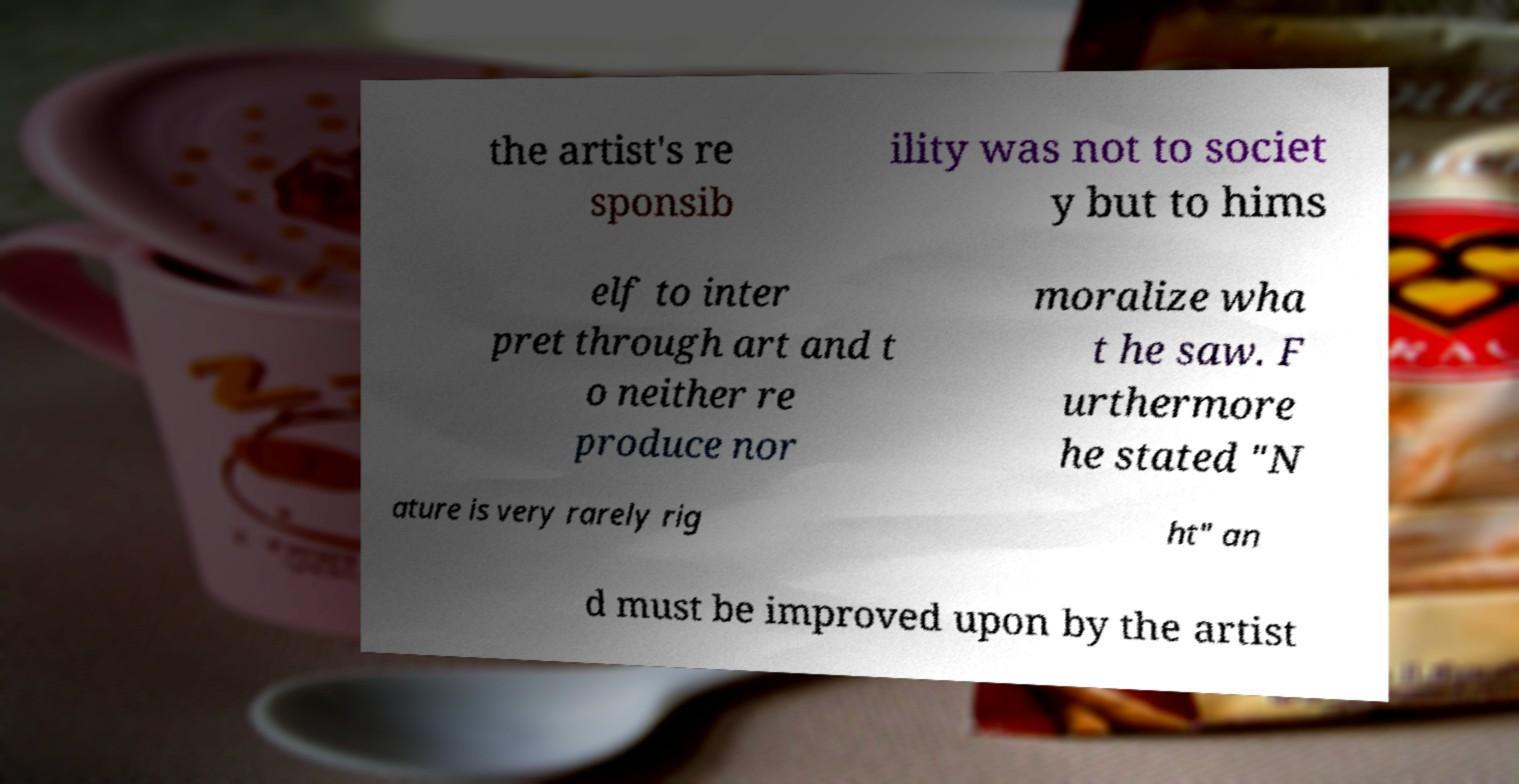Can you accurately transcribe the text from the provided image for me? the artist's re sponsib ility was not to societ y but to hims elf to inter pret through art and t o neither re produce nor moralize wha t he saw. F urthermore he stated "N ature is very rarely rig ht" an d must be improved upon by the artist 